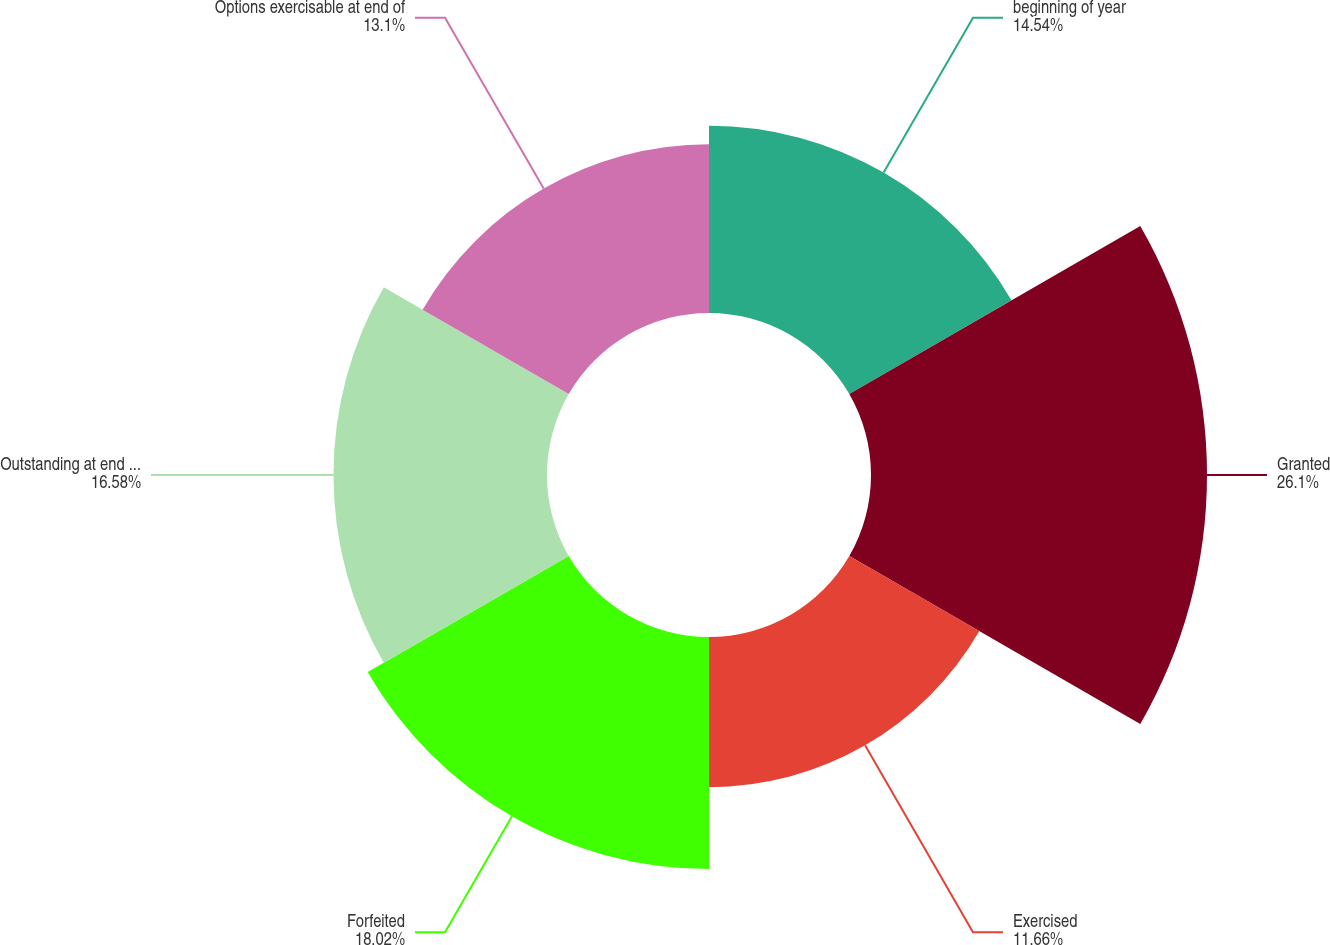Convert chart. <chart><loc_0><loc_0><loc_500><loc_500><pie_chart><fcel>beginning of year<fcel>Granted<fcel>Exercised<fcel>Forfeited<fcel>Outstanding at end of year<fcel>Options exercisable at end of<nl><fcel>14.54%<fcel>26.09%<fcel>11.66%<fcel>18.02%<fcel>16.58%<fcel>13.1%<nl></chart> 